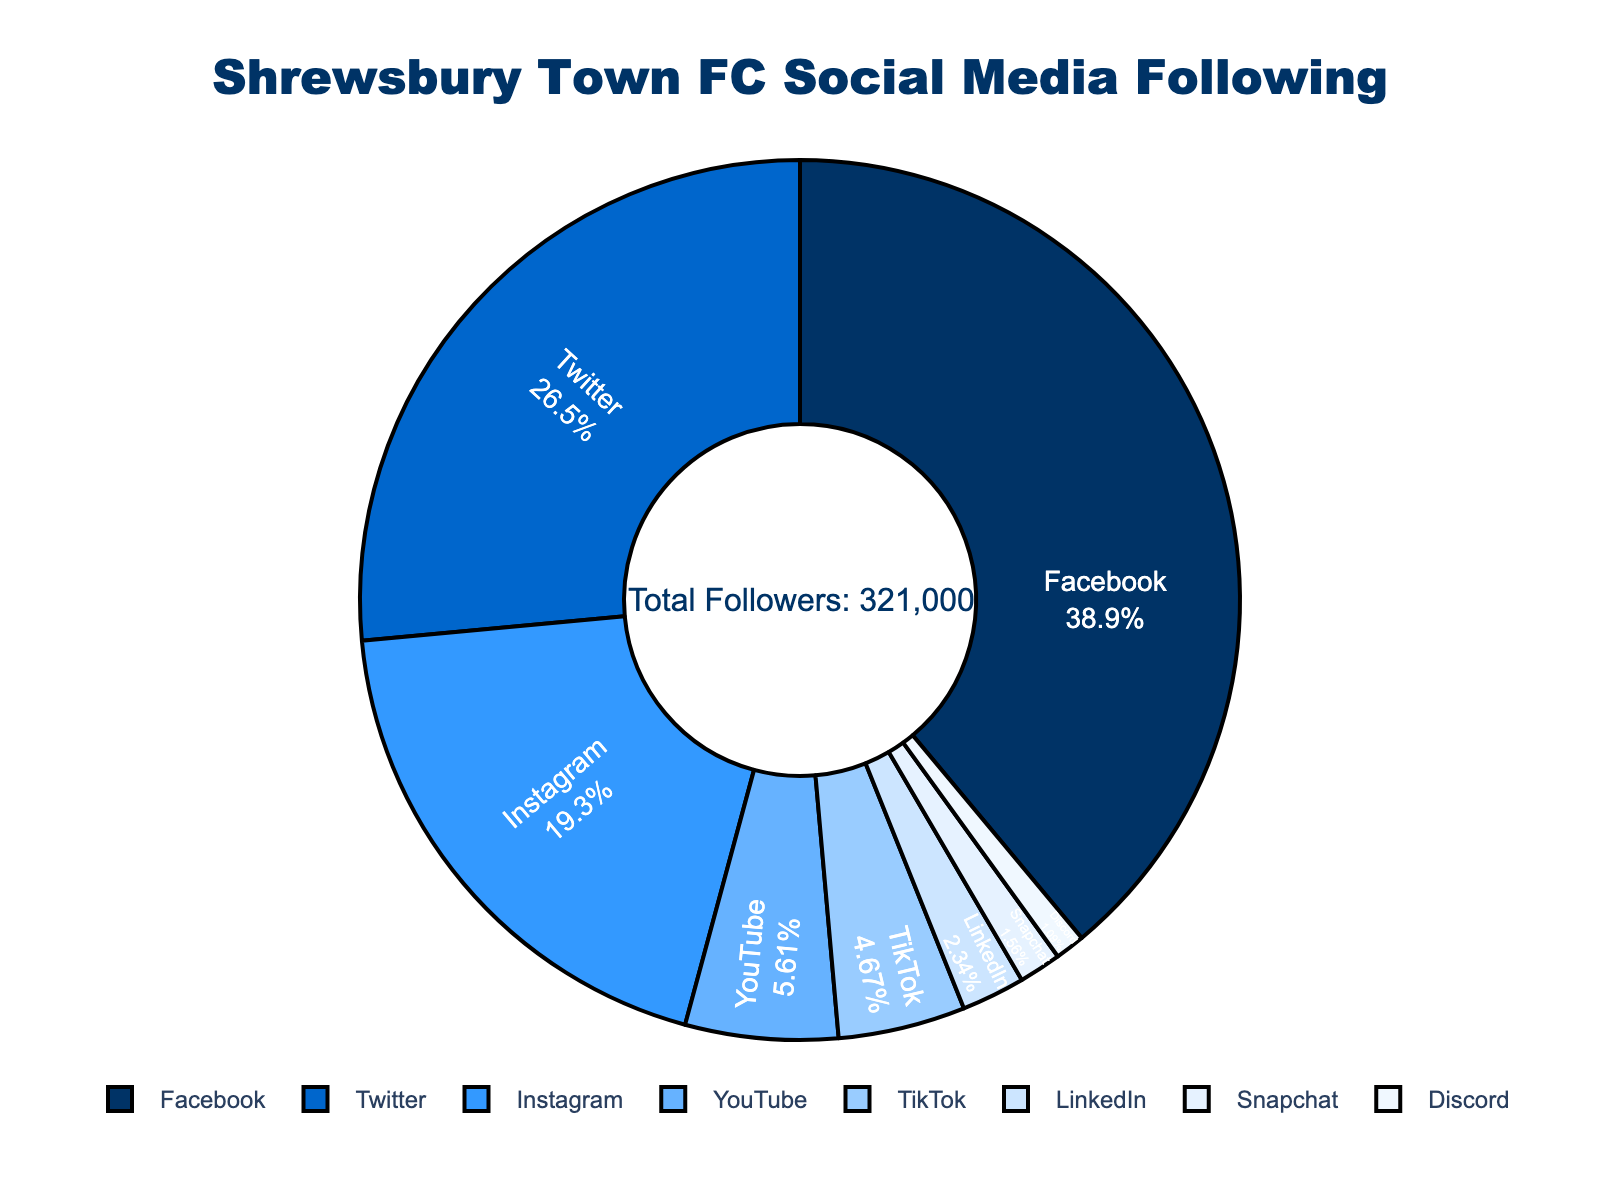What's the largest social media following platform for Shrewsbury Town FC? The largest segment of the pie chart represents the platform with the highest number of followers. Facebook's segment is the largest, indicating its 125,000 followers.
Answer: Facebook What percentage of followers does Instagram have? The percentage is indicated inside each pie segment. The segment for Instagram shows the percentage value directly.
Answer: 21.1% How many more followers does Twitter have compared to TikTok? To find the difference, subtract the number of TikTok followers from Twitter followers. Twitter has 85,000 followers, and TikTok has 15,000 followers. 85,000 - 15,000 = 70,000.
Answer: 70,000 Which platforms have fewer followers than YouTube? To determine this, look at the segments smaller than YouTube's and check their labels. The platforms with fewer followers than YouTube (18,000) are LinkedIn (7,500), Snapchat (5,000), and Discord (3,500).
Answer: LinkedIn, Snapchat, Discord Are there more followers on TikTok and LinkedIn combined than on Instagram? Add the followers of TikTok (15,000) and LinkedIn (7,500), and compare this sum to the followers of Instagram (62,000). 15,000 + 7,500 = 22,500, which is less than 62,000.
Answer: No What is the total number of followers across all platforms? Add all followers: 125,000 (Facebook) + 85,000 (Twitter) + 62,000 (Instagram) + 18,000 (YouTube) + 15,000 (TikTok) + 7,500 (LinkedIn) + 5,000 (Snapchat) + 3,500 (Discord) = 321,000.
Answer: 321,000 Which platform has the smallest percentage of the total followers? The smallest segment on the pie chart represents the platform with the lowest percentage of followers. This is Discord.
Answer: Discord How does the number of Snapchat followers compare to LinkedIn followers? Compare the segments' sizes for Snapchat and LinkedIn. Snapchat has 5,000 followers, and LinkedIn has 7,500 followers. Thus, Snapchat has fewer followers than LinkedIn.
Answer: Snapchat has fewer followers than LinkedIn What proportion of the total followers are on Facebook and Twitter together? Add the followers of both Facebook (125,000) and Twitter (85,000) and then divide by the total followers (321,000). (125,000 + 85,000) / 321,000 = 210,000 / 321,000 ≈ 0.6542 or 65.42%.
Answer: 65.42% How many followers are on platforms with over 20,000 followers? Identify platforms with over 20,000 followers (Facebook, Twitter, and Instagram), then sum their followers: 125,000 (Facebook) + 85,000 (Twitter) + 62,000 (Instagram) = 272,000.
Answer: 272,000 